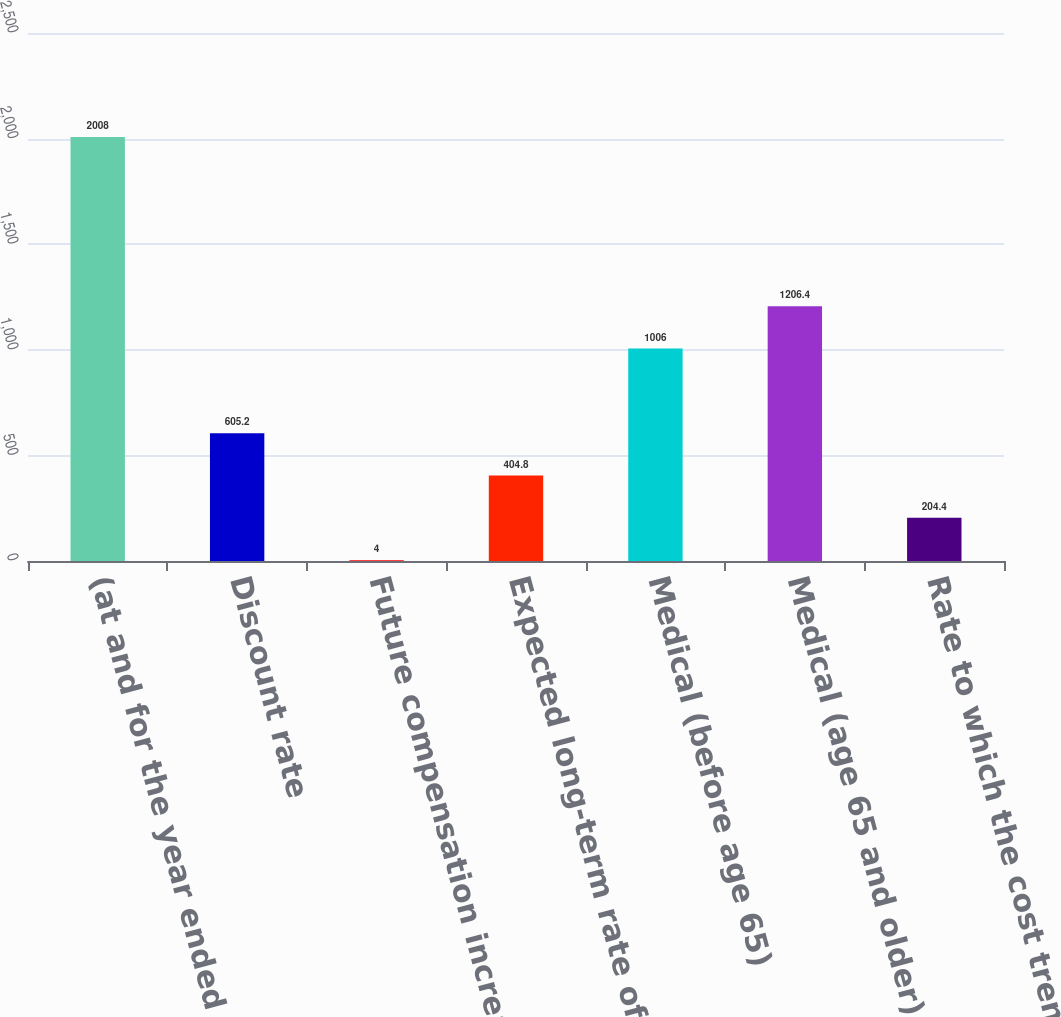Convert chart. <chart><loc_0><loc_0><loc_500><loc_500><bar_chart><fcel>(at and for the year ended<fcel>Discount rate<fcel>Future compensation increase<fcel>Expected long-term rate of<fcel>Medical (before age 65)<fcel>Medical (age 65 and older)<fcel>Rate to which the cost trend<nl><fcel>2008<fcel>605.2<fcel>4<fcel>404.8<fcel>1006<fcel>1206.4<fcel>204.4<nl></chart> 